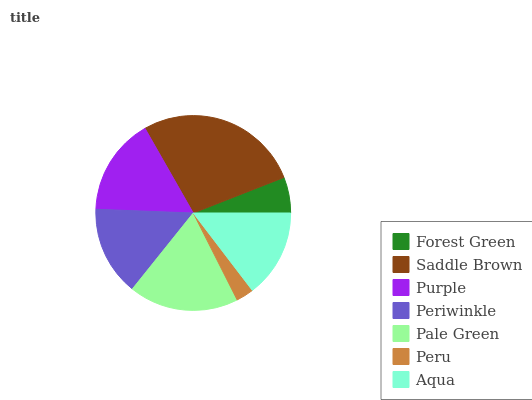Is Peru the minimum?
Answer yes or no. Yes. Is Saddle Brown the maximum?
Answer yes or no. Yes. Is Purple the minimum?
Answer yes or no. No. Is Purple the maximum?
Answer yes or no. No. Is Saddle Brown greater than Purple?
Answer yes or no. Yes. Is Purple less than Saddle Brown?
Answer yes or no. Yes. Is Purple greater than Saddle Brown?
Answer yes or no. No. Is Saddle Brown less than Purple?
Answer yes or no. No. Is Periwinkle the high median?
Answer yes or no. Yes. Is Periwinkle the low median?
Answer yes or no. Yes. Is Peru the high median?
Answer yes or no. No. Is Pale Green the low median?
Answer yes or no. No. 